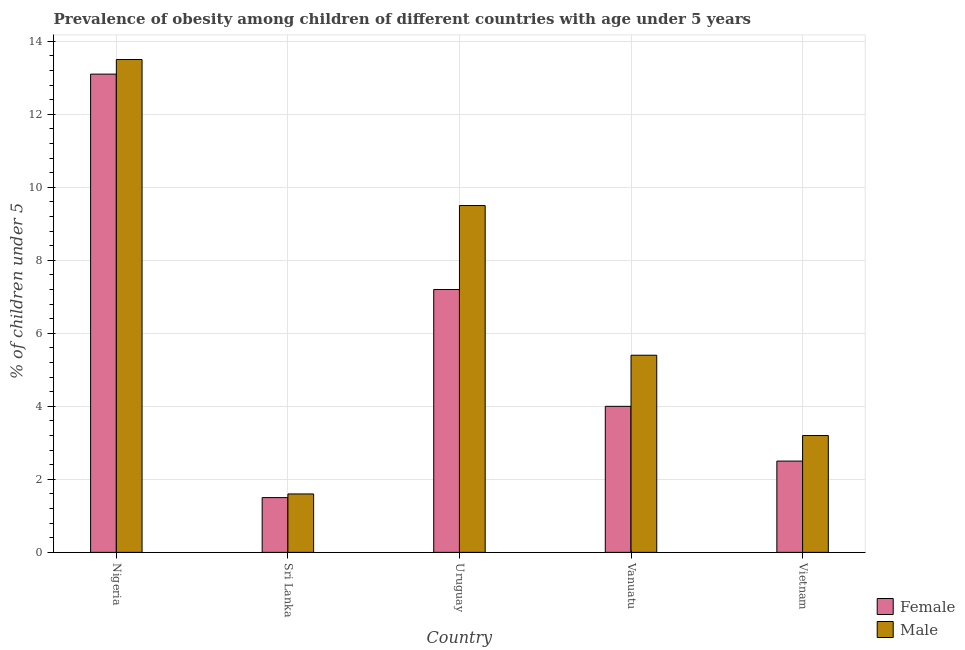How many different coloured bars are there?
Ensure brevity in your answer.  2. How many groups of bars are there?
Offer a very short reply. 5. Are the number of bars per tick equal to the number of legend labels?
Offer a terse response. Yes. How many bars are there on the 4th tick from the left?
Your answer should be compact. 2. What is the label of the 1st group of bars from the left?
Provide a short and direct response. Nigeria. What is the percentage of obese male children in Vietnam?
Offer a terse response. 3.2. Across all countries, what is the minimum percentage of obese female children?
Ensure brevity in your answer.  1.5. In which country was the percentage of obese male children maximum?
Your answer should be compact. Nigeria. In which country was the percentage of obese female children minimum?
Make the answer very short. Sri Lanka. What is the total percentage of obese female children in the graph?
Make the answer very short. 28.3. What is the difference between the percentage of obese female children in Nigeria and that in Uruguay?
Provide a succinct answer. 5.9. What is the average percentage of obese male children per country?
Provide a short and direct response. 6.64. What is the difference between the percentage of obese female children and percentage of obese male children in Uruguay?
Your answer should be compact. -2.3. What is the ratio of the percentage of obese male children in Vanuatu to that in Vietnam?
Provide a short and direct response. 1.69. Is the difference between the percentage of obese female children in Nigeria and Vietnam greater than the difference between the percentage of obese male children in Nigeria and Vietnam?
Offer a terse response. Yes. What is the difference between the highest and the second highest percentage of obese male children?
Offer a very short reply. 4. What is the difference between the highest and the lowest percentage of obese male children?
Make the answer very short. 11.9. In how many countries, is the percentage of obese male children greater than the average percentage of obese male children taken over all countries?
Offer a terse response. 2. Is the sum of the percentage of obese male children in Vanuatu and Vietnam greater than the maximum percentage of obese female children across all countries?
Offer a terse response. No. What does the 1st bar from the left in Nigeria represents?
Offer a very short reply. Female. Are all the bars in the graph horizontal?
Your answer should be compact. No. How many countries are there in the graph?
Offer a very short reply. 5. Does the graph contain grids?
Provide a short and direct response. Yes. Where does the legend appear in the graph?
Your response must be concise. Bottom right. How many legend labels are there?
Offer a very short reply. 2. How are the legend labels stacked?
Your answer should be very brief. Vertical. What is the title of the graph?
Your answer should be very brief. Prevalence of obesity among children of different countries with age under 5 years. What is the label or title of the X-axis?
Make the answer very short. Country. What is the label or title of the Y-axis?
Provide a short and direct response.  % of children under 5. What is the  % of children under 5 in Female in Nigeria?
Offer a very short reply. 13.1. What is the  % of children under 5 in Female in Sri Lanka?
Your response must be concise. 1.5. What is the  % of children under 5 of Male in Sri Lanka?
Offer a very short reply. 1.6. What is the  % of children under 5 in Female in Uruguay?
Your answer should be very brief. 7.2. What is the  % of children under 5 of Female in Vanuatu?
Keep it short and to the point. 4. What is the  % of children under 5 in Male in Vanuatu?
Keep it short and to the point. 5.4. What is the  % of children under 5 in Female in Vietnam?
Ensure brevity in your answer.  2.5. What is the  % of children under 5 in Male in Vietnam?
Provide a succinct answer. 3.2. Across all countries, what is the maximum  % of children under 5 of Female?
Your response must be concise. 13.1. Across all countries, what is the minimum  % of children under 5 of Female?
Provide a succinct answer. 1.5. Across all countries, what is the minimum  % of children under 5 of Male?
Provide a short and direct response. 1.6. What is the total  % of children under 5 of Female in the graph?
Provide a succinct answer. 28.3. What is the total  % of children under 5 in Male in the graph?
Provide a succinct answer. 33.2. What is the difference between the  % of children under 5 of Female in Nigeria and that in Sri Lanka?
Give a very brief answer. 11.6. What is the difference between the  % of children under 5 in Female in Nigeria and that in Vanuatu?
Your response must be concise. 9.1. What is the difference between the  % of children under 5 of Male in Nigeria and that in Vanuatu?
Keep it short and to the point. 8.1. What is the difference between the  % of children under 5 in Female in Nigeria and that in Vietnam?
Make the answer very short. 10.6. What is the difference between the  % of children under 5 in Female in Sri Lanka and that in Uruguay?
Make the answer very short. -5.7. What is the difference between the  % of children under 5 in Male in Sri Lanka and that in Uruguay?
Provide a short and direct response. -7.9. What is the difference between the  % of children under 5 of Female in Sri Lanka and that in Vanuatu?
Your answer should be very brief. -2.5. What is the difference between the  % of children under 5 in Male in Sri Lanka and that in Vietnam?
Ensure brevity in your answer.  -1.6. What is the difference between the  % of children under 5 in Female in Vanuatu and that in Vietnam?
Make the answer very short. 1.5. What is the difference between the  % of children under 5 of Male in Vanuatu and that in Vietnam?
Offer a very short reply. 2.2. What is the difference between the  % of children under 5 of Female in Nigeria and the  % of children under 5 of Male in Sri Lanka?
Offer a very short reply. 11.5. What is the difference between the  % of children under 5 of Female in Nigeria and the  % of children under 5 of Male in Uruguay?
Your response must be concise. 3.6. What is the difference between the  % of children under 5 of Female in Nigeria and the  % of children under 5 of Male in Vanuatu?
Offer a terse response. 7.7. What is the difference between the  % of children under 5 in Female in Nigeria and the  % of children under 5 in Male in Vietnam?
Ensure brevity in your answer.  9.9. What is the difference between the  % of children under 5 in Female in Sri Lanka and the  % of children under 5 in Male in Uruguay?
Your answer should be compact. -8. What is the difference between the  % of children under 5 of Female in Uruguay and the  % of children under 5 of Male in Vanuatu?
Make the answer very short. 1.8. What is the difference between the  % of children under 5 in Female in Uruguay and the  % of children under 5 in Male in Vietnam?
Provide a succinct answer. 4. What is the average  % of children under 5 of Female per country?
Give a very brief answer. 5.66. What is the average  % of children under 5 in Male per country?
Make the answer very short. 6.64. What is the difference between the  % of children under 5 in Female and  % of children under 5 in Male in Sri Lanka?
Provide a succinct answer. -0.1. What is the difference between the  % of children under 5 in Female and  % of children under 5 in Male in Vanuatu?
Offer a very short reply. -1.4. What is the difference between the  % of children under 5 of Female and  % of children under 5 of Male in Vietnam?
Make the answer very short. -0.7. What is the ratio of the  % of children under 5 of Female in Nigeria to that in Sri Lanka?
Give a very brief answer. 8.73. What is the ratio of the  % of children under 5 in Male in Nigeria to that in Sri Lanka?
Give a very brief answer. 8.44. What is the ratio of the  % of children under 5 in Female in Nigeria to that in Uruguay?
Give a very brief answer. 1.82. What is the ratio of the  % of children under 5 in Male in Nigeria to that in Uruguay?
Make the answer very short. 1.42. What is the ratio of the  % of children under 5 of Female in Nigeria to that in Vanuatu?
Keep it short and to the point. 3.27. What is the ratio of the  % of children under 5 in Male in Nigeria to that in Vanuatu?
Provide a succinct answer. 2.5. What is the ratio of the  % of children under 5 in Female in Nigeria to that in Vietnam?
Make the answer very short. 5.24. What is the ratio of the  % of children under 5 of Male in Nigeria to that in Vietnam?
Offer a terse response. 4.22. What is the ratio of the  % of children under 5 of Female in Sri Lanka to that in Uruguay?
Give a very brief answer. 0.21. What is the ratio of the  % of children under 5 of Male in Sri Lanka to that in Uruguay?
Make the answer very short. 0.17. What is the ratio of the  % of children under 5 of Male in Sri Lanka to that in Vanuatu?
Your response must be concise. 0.3. What is the ratio of the  % of children under 5 of Female in Sri Lanka to that in Vietnam?
Your answer should be very brief. 0.6. What is the ratio of the  % of children under 5 in Male in Sri Lanka to that in Vietnam?
Make the answer very short. 0.5. What is the ratio of the  % of children under 5 of Female in Uruguay to that in Vanuatu?
Give a very brief answer. 1.8. What is the ratio of the  % of children under 5 of Male in Uruguay to that in Vanuatu?
Provide a succinct answer. 1.76. What is the ratio of the  % of children under 5 of Female in Uruguay to that in Vietnam?
Offer a terse response. 2.88. What is the ratio of the  % of children under 5 of Male in Uruguay to that in Vietnam?
Provide a succinct answer. 2.97. What is the ratio of the  % of children under 5 of Female in Vanuatu to that in Vietnam?
Offer a terse response. 1.6. What is the ratio of the  % of children under 5 of Male in Vanuatu to that in Vietnam?
Provide a succinct answer. 1.69. What is the difference between the highest and the second highest  % of children under 5 in Male?
Keep it short and to the point. 4. What is the difference between the highest and the lowest  % of children under 5 of Male?
Ensure brevity in your answer.  11.9. 